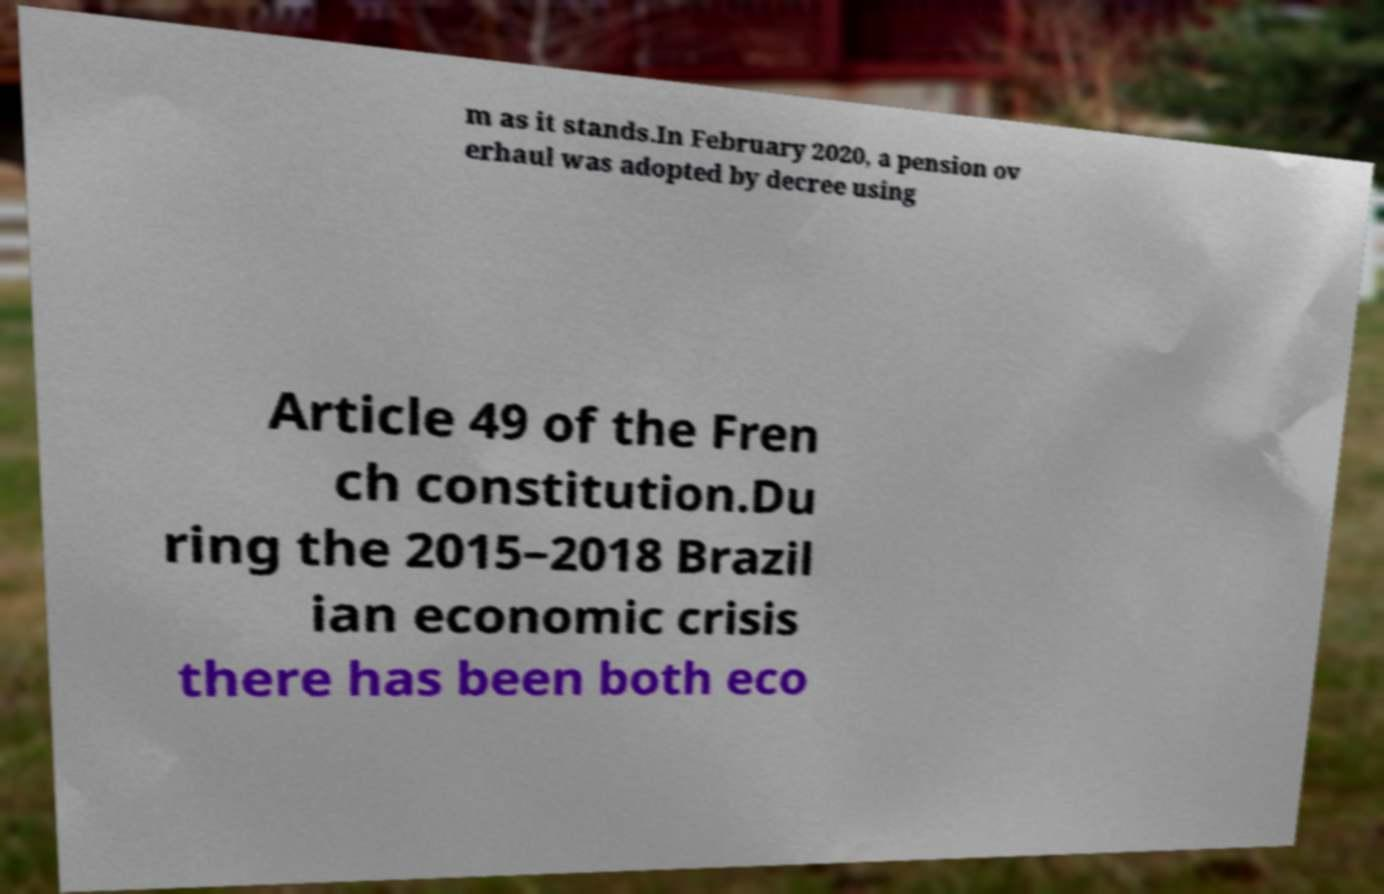Can you read and provide the text displayed in the image?This photo seems to have some interesting text. Can you extract and type it out for me? m as it stands.In February 2020, a pension ov erhaul was adopted by decree using Article 49 of the Fren ch constitution.Du ring the 2015–2018 Brazil ian economic crisis there has been both eco 